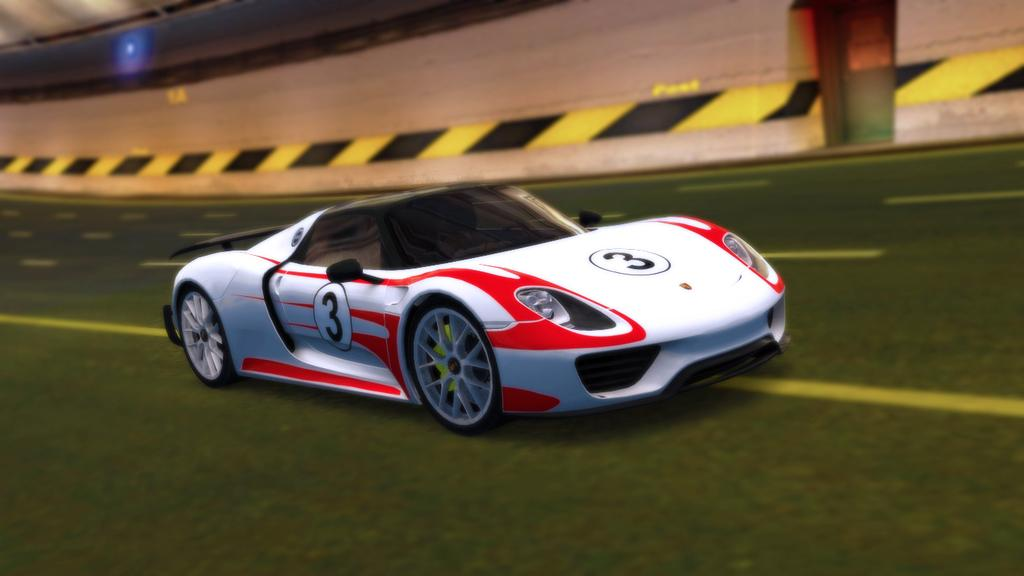What is the main subject of the image? There is a vehicle in the image. Where is the vehicle located? The vehicle is on the road. How many wings does the vehicle have in the image? The vehicle does not have any wings, as it is not an aircraft. What type of fire can be seen coming from the vehicle in the image? There is no fire present in the image; the vehicle is simply on the road. 